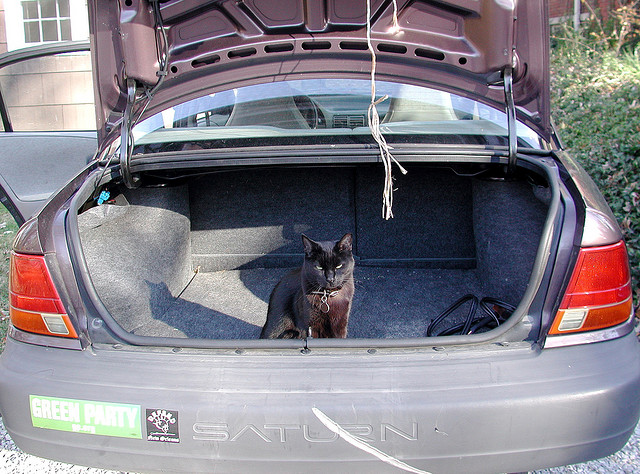Please transcribe the text information in this image. GREEN 